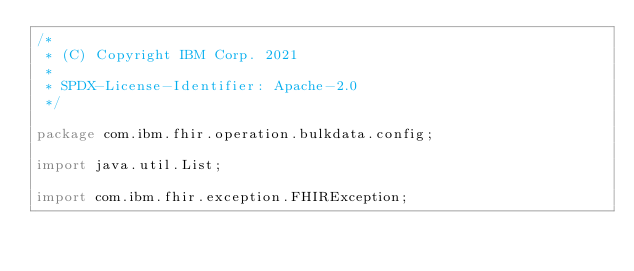Convert code to text. <code><loc_0><loc_0><loc_500><loc_500><_Java_>/*
 * (C) Copyright IBM Corp. 2021
 *
 * SPDX-License-Identifier: Apache-2.0
 */

package com.ibm.fhir.operation.bulkdata.config;

import java.util.List;

import com.ibm.fhir.exception.FHIRException;</code> 